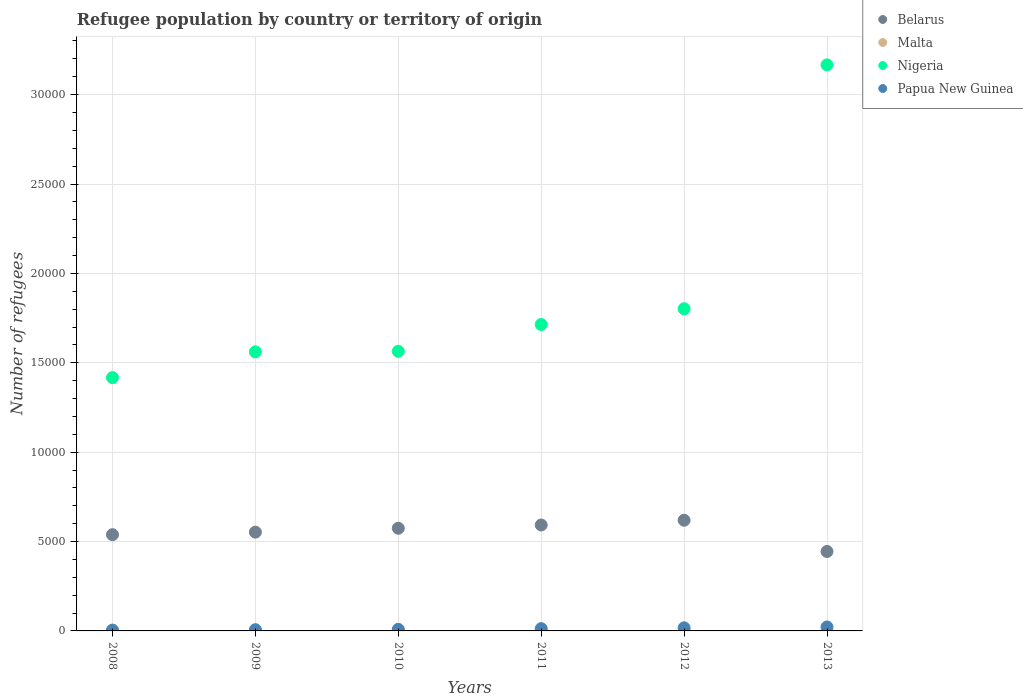Is the number of dotlines equal to the number of legend labels?
Your answer should be compact. Yes. Across all years, what is the minimum number of refugees in Nigeria?
Your answer should be very brief. 1.42e+04. What is the difference between the number of refugees in Nigeria in 2010 and that in 2012?
Your response must be concise. -2379. What is the difference between the number of refugees in Belarus in 2013 and the number of refugees in Nigeria in 2012?
Make the answer very short. -1.36e+04. What is the average number of refugees in Nigeria per year?
Offer a very short reply. 1.87e+04. In the year 2008, what is the difference between the number of refugees in Belarus and number of refugees in Papua New Guinea?
Your answer should be compact. 5338. What is the ratio of the number of refugees in Papua New Guinea in 2010 to that in 2013?
Keep it short and to the point. 0.4. Is the number of refugees in Malta in 2011 less than that in 2013?
Ensure brevity in your answer.  No. Is it the case that in every year, the sum of the number of refugees in Malta and number of refugees in Papua New Guinea  is greater than the sum of number of refugees in Nigeria and number of refugees in Belarus?
Offer a very short reply. No. Does the number of refugees in Nigeria monotonically increase over the years?
Ensure brevity in your answer.  Yes. Is the number of refugees in Belarus strictly greater than the number of refugees in Papua New Guinea over the years?
Your response must be concise. Yes. How many years are there in the graph?
Provide a succinct answer. 6. What is the difference between two consecutive major ticks on the Y-axis?
Your response must be concise. 5000. Does the graph contain grids?
Give a very brief answer. Yes. How are the legend labels stacked?
Give a very brief answer. Vertical. What is the title of the graph?
Keep it short and to the point. Refugee population by country or territory of origin. What is the label or title of the X-axis?
Offer a very short reply. Years. What is the label or title of the Y-axis?
Your answer should be very brief. Number of refugees. What is the Number of refugees in Belarus in 2008?
Your response must be concise. 5384. What is the Number of refugees in Nigeria in 2008?
Your response must be concise. 1.42e+04. What is the Number of refugees of Belarus in 2009?
Offer a terse response. 5525. What is the Number of refugees of Malta in 2009?
Provide a succinct answer. 9. What is the Number of refugees of Nigeria in 2009?
Provide a short and direct response. 1.56e+04. What is the Number of refugees in Papua New Guinea in 2009?
Provide a succinct answer. 70. What is the Number of refugees of Belarus in 2010?
Your response must be concise. 5743. What is the Number of refugees in Nigeria in 2010?
Provide a short and direct response. 1.56e+04. What is the Number of refugees in Papua New Guinea in 2010?
Give a very brief answer. 89. What is the Number of refugees in Belarus in 2011?
Provide a short and direct response. 5925. What is the Number of refugees in Nigeria in 2011?
Make the answer very short. 1.71e+04. What is the Number of refugees of Papua New Guinea in 2011?
Offer a terse response. 128. What is the Number of refugees of Belarus in 2012?
Make the answer very short. 6191. What is the Number of refugees of Malta in 2012?
Ensure brevity in your answer.  6. What is the Number of refugees in Nigeria in 2012?
Keep it short and to the point. 1.80e+04. What is the Number of refugees in Papua New Guinea in 2012?
Make the answer very short. 174. What is the Number of refugees of Belarus in 2013?
Offer a very short reply. 4444. What is the Number of refugees in Malta in 2013?
Provide a short and direct response. 6. What is the Number of refugees in Nigeria in 2013?
Keep it short and to the point. 3.17e+04. What is the Number of refugees in Papua New Guinea in 2013?
Make the answer very short. 221. Across all years, what is the maximum Number of refugees of Belarus?
Provide a succinct answer. 6191. Across all years, what is the maximum Number of refugees in Nigeria?
Give a very brief answer. 3.17e+04. Across all years, what is the maximum Number of refugees in Papua New Guinea?
Offer a terse response. 221. Across all years, what is the minimum Number of refugees of Belarus?
Provide a short and direct response. 4444. Across all years, what is the minimum Number of refugees in Nigeria?
Your answer should be compact. 1.42e+04. Across all years, what is the minimum Number of refugees of Papua New Guinea?
Keep it short and to the point. 46. What is the total Number of refugees of Belarus in the graph?
Make the answer very short. 3.32e+04. What is the total Number of refugees in Malta in the graph?
Your response must be concise. 42. What is the total Number of refugees of Nigeria in the graph?
Offer a very short reply. 1.12e+05. What is the total Number of refugees in Papua New Guinea in the graph?
Offer a terse response. 728. What is the difference between the Number of refugees of Belarus in 2008 and that in 2009?
Keep it short and to the point. -141. What is the difference between the Number of refugees in Malta in 2008 and that in 2009?
Your answer should be very brief. 0. What is the difference between the Number of refugees of Nigeria in 2008 and that in 2009?
Ensure brevity in your answer.  -1440. What is the difference between the Number of refugees of Belarus in 2008 and that in 2010?
Your answer should be compact. -359. What is the difference between the Number of refugees in Nigeria in 2008 and that in 2010?
Your response must be concise. -1473. What is the difference between the Number of refugees in Papua New Guinea in 2008 and that in 2010?
Ensure brevity in your answer.  -43. What is the difference between the Number of refugees in Belarus in 2008 and that in 2011?
Offer a very short reply. -541. What is the difference between the Number of refugees of Malta in 2008 and that in 2011?
Your response must be concise. 3. What is the difference between the Number of refugees in Nigeria in 2008 and that in 2011?
Make the answer very short. -2972. What is the difference between the Number of refugees in Papua New Guinea in 2008 and that in 2011?
Your response must be concise. -82. What is the difference between the Number of refugees of Belarus in 2008 and that in 2012?
Your response must be concise. -807. What is the difference between the Number of refugees of Nigeria in 2008 and that in 2012?
Offer a terse response. -3852. What is the difference between the Number of refugees in Papua New Guinea in 2008 and that in 2012?
Keep it short and to the point. -128. What is the difference between the Number of refugees in Belarus in 2008 and that in 2013?
Your response must be concise. 940. What is the difference between the Number of refugees of Nigeria in 2008 and that in 2013?
Offer a very short reply. -1.75e+04. What is the difference between the Number of refugees in Papua New Guinea in 2008 and that in 2013?
Make the answer very short. -175. What is the difference between the Number of refugees in Belarus in 2009 and that in 2010?
Give a very brief answer. -218. What is the difference between the Number of refugees in Nigeria in 2009 and that in 2010?
Make the answer very short. -33. What is the difference between the Number of refugees of Papua New Guinea in 2009 and that in 2010?
Your answer should be very brief. -19. What is the difference between the Number of refugees in Belarus in 2009 and that in 2011?
Provide a short and direct response. -400. What is the difference between the Number of refugees in Nigeria in 2009 and that in 2011?
Give a very brief answer. -1532. What is the difference between the Number of refugees in Papua New Guinea in 2009 and that in 2011?
Your answer should be compact. -58. What is the difference between the Number of refugees in Belarus in 2009 and that in 2012?
Your response must be concise. -666. What is the difference between the Number of refugees in Nigeria in 2009 and that in 2012?
Provide a short and direct response. -2412. What is the difference between the Number of refugees in Papua New Guinea in 2009 and that in 2012?
Offer a terse response. -104. What is the difference between the Number of refugees in Belarus in 2009 and that in 2013?
Ensure brevity in your answer.  1081. What is the difference between the Number of refugees in Malta in 2009 and that in 2013?
Provide a short and direct response. 3. What is the difference between the Number of refugees in Nigeria in 2009 and that in 2013?
Offer a terse response. -1.61e+04. What is the difference between the Number of refugees of Papua New Guinea in 2009 and that in 2013?
Make the answer very short. -151. What is the difference between the Number of refugees in Belarus in 2010 and that in 2011?
Offer a very short reply. -182. What is the difference between the Number of refugees of Nigeria in 2010 and that in 2011?
Give a very brief answer. -1499. What is the difference between the Number of refugees in Papua New Guinea in 2010 and that in 2011?
Your answer should be compact. -39. What is the difference between the Number of refugees of Belarus in 2010 and that in 2012?
Offer a terse response. -448. What is the difference between the Number of refugees of Nigeria in 2010 and that in 2012?
Your answer should be very brief. -2379. What is the difference between the Number of refugees of Papua New Guinea in 2010 and that in 2012?
Your answer should be compact. -85. What is the difference between the Number of refugees of Belarus in 2010 and that in 2013?
Provide a short and direct response. 1299. What is the difference between the Number of refugees in Nigeria in 2010 and that in 2013?
Provide a short and direct response. -1.60e+04. What is the difference between the Number of refugees in Papua New Guinea in 2010 and that in 2013?
Your answer should be very brief. -132. What is the difference between the Number of refugees in Belarus in 2011 and that in 2012?
Your answer should be very brief. -266. What is the difference between the Number of refugees of Malta in 2011 and that in 2012?
Provide a succinct answer. 0. What is the difference between the Number of refugees in Nigeria in 2011 and that in 2012?
Your answer should be very brief. -880. What is the difference between the Number of refugees in Papua New Guinea in 2011 and that in 2012?
Provide a short and direct response. -46. What is the difference between the Number of refugees in Belarus in 2011 and that in 2013?
Offer a terse response. 1481. What is the difference between the Number of refugees in Malta in 2011 and that in 2013?
Offer a terse response. 0. What is the difference between the Number of refugees in Nigeria in 2011 and that in 2013?
Make the answer very short. -1.45e+04. What is the difference between the Number of refugees in Papua New Guinea in 2011 and that in 2013?
Your response must be concise. -93. What is the difference between the Number of refugees in Belarus in 2012 and that in 2013?
Your answer should be very brief. 1747. What is the difference between the Number of refugees in Malta in 2012 and that in 2013?
Provide a succinct answer. 0. What is the difference between the Number of refugees of Nigeria in 2012 and that in 2013?
Your response must be concise. -1.36e+04. What is the difference between the Number of refugees of Papua New Guinea in 2012 and that in 2013?
Your answer should be compact. -47. What is the difference between the Number of refugees in Belarus in 2008 and the Number of refugees in Malta in 2009?
Keep it short and to the point. 5375. What is the difference between the Number of refugees in Belarus in 2008 and the Number of refugees in Nigeria in 2009?
Keep it short and to the point. -1.02e+04. What is the difference between the Number of refugees of Belarus in 2008 and the Number of refugees of Papua New Guinea in 2009?
Offer a terse response. 5314. What is the difference between the Number of refugees in Malta in 2008 and the Number of refugees in Nigeria in 2009?
Keep it short and to the point. -1.56e+04. What is the difference between the Number of refugees in Malta in 2008 and the Number of refugees in Papua New Guinea in 2009?
Make the answer very short. -61. What is the difference between the Number of refugees in Nigeria in 2008 and the Number of refugees in Papua New Guinea in 2009?
Offer a terse response. 1.41e+04. What is the difference between the Number of refugees of Belarus in 2008 and the Number of refugees of Malta in 2010?
Provide a succinct answer. 5378. What is the difference between the Number of refugees in Belarus in 2008 and the Number of refugees in Nigeria in 2010?
Offer a very short reply. -1.03e+04. What is the difference between the Number of refugees of Belarus in 2008 and the Number of refugees of Papua New Guinea in 2010?
Give a very brief answer. 5295. What is the difference between the Number of refugees of Malta in 2008 and the Number of refugees of Nigeria in 2010?
Your response must be concise. -1.56e+04. What is the difference between the Number of refugees in Malta in 2008 and the Number of refugees in Papua New Guinea in 2010?
Your answer should be very brief. -80. What is the difference between the Number of refugees in Nigeria in 2008 and the Number of refugees in Papua New Guinea in 2010?
Give a very brief answer. 1.41e+04. What is the difference between the Number of refugees in Belarus in 2008 and the Number of refugees in Malta in 2011?
Provide a succinct answer. 5378. What is the difference between the Number of refugees in Belarus in 2008 and the Number of refugees in Nigeria in 2011?
Make the answer very short. -1.18e+04. What is the difference between the Number of refugees of Belarus in 2008 and the Number of refugees of Papua New Guinea in 2011?
Provide a short and direct response. 5256. What is the difference between the Number of refugees in Malta in 2008 and the Number of refugees in Nigeria in 2011?
Ensure brevity in your answer.  -1.71e+04. What is the difference between the Number of refugees in Malta in 2008 and the Number of refugees in Papua New Guinea in 2011?
Provide a short and direct response. -119. What is the difference between the Number of refugees of Nigeria in 2008 and the Number of refugees of Papua New Guinea in 2011?
Your answer should be very brief. 1.40e+04. What is the difference between the Number of refugees of Belarus in 2008 and the Number of refugees of Malta in 2012?
Provide a succinct answer. 5378. What is the difference between the Number of refugees of Belarus in 2008 and the Number of refugees of Nigeria in 2012?
Provide a succinct answer. -1.26e+04. What is the difference between the Number of refugees of Belarus in 2008 and the Number of refugees of Papua New Guinea in 2012?
Provide a short and direct response. 5210. What is the difference between the Number of refugees of Malta in 2008 and the Number of refugees of Nigeria in 2012?
Ensure brevity in your answer.  -1.80e+04. What is the difference between the Number of refugees in Malta in 2008 and the Number of refugees in Papua New Guinea in 2012?
Make the answer very short. -165. What is the difference between the Number of refugees of Nigeria in 2008 and the Number of refugees of Papua New Guinea in 2012?
Your answer should be very brief. 1.40e+04. What is the difference between the Number of refugees in Belarus in 2008 and the Number of refugees in Malta in 2013?
Provide a short and direct response. 5378. What is the difference between the Number of refugees in Belarus in 2008 and the Number of refugees in Nigeria in 2013?
Ensure brevity in your answer.  -2.63e+04. What is the difference between the Number of refugees of Belarus in 2008 and the Number of refugees of Papua New Guinea in 2013?
Provide a short and direct response. 5163. What is the difference between the Number of refugees in Malta in 2008 and the Number of refugees in Nigeria in 2013?
Offer a very short reply. -3.17e+04. What is the difference between the Number of refugees of Malta in 2008 and the Number of refugees of Papua New Guinea in 2013?
Provide a succinct answer. -212. What is the difference between the Number of refugees of Nigeria in 2008 and the Number of refugees of Papua New Guinea in 2013?
Keep it short and to the point. 1.39e+04. What is the difference between the Number of refugees in Belarus in 2009 and the Number of refugees in Malta in 2010?
Provide a short and direct response. 5519. What is the difference between the Number of refugees in Belarus in 2009 and the Number of refugees in Nigeria in 2010?
Ensure brevity in your answer.  -1.01e+04. What is the difference between the Number of refugees in Belarus in 2009 and the Number of refugees in Papua New Guinea in 2010?
Ensure brevity in your answer.  5436. What is the difference between the Number of refugees in Malta in 2009 and the Number of refugees in Nigeria in 2010?
Provide a succinct answer. -1.56e+04. What is the difference between the Number of refugees of Malta in 2009 and the Number of refugees of Papua New Guinea in 2010?
Offer a terse response. -80. What is the difference between the Number of refugees in Nigeria in 2009 and the Number of refugees in Papua New Guinea in 2010?
Offer a very short reply. 1.55e+04. What is the difference between the Number of refugees in Belarus in 2009 and the Number of refugees in Malta in 2011?
Provide a succinct answer. 5519. What is the difference between the Number of refugees in Belarus in 2009 and the Number of refugees in Nigeria in 2011?
Provide a short and direct response. -1.16e+04. What is the difference between the Number of refugees in Belarus in 2009 and the Number of refugees in Papua New Guinea in 2011?
Make the answer very short. 5397. What is the difference between the Number of refugees of Malta in 2009 and the Number of refugees of Nigeria in 2011?
Your response must be concise. -1.71e+04. What is the difference between the Number of refugees in Malta in 2009 and the Number of refugees in Papua New Guinea in 2011?
Your answer should be compact. -119. What is the difference between the Number of refugees in Nigeria in 2009 and the Number of refugees in Papua New Guinea in 2011?
Your answer should be very brief. 1.55e+04. What is the difference between the Number of refugees in Belarus in 2009 and the Number of refugees in Malta in 2012?
Give a very brief answer. 5519. What is the difference between the Number of refugees of Belarus in 2009 and the Number of refugees of Nigeria in 2012?
Make the answer very short. -1.25e+04. What is the difference between the Number of refugees in Belarus in 2009 and the Number of refugees in Papua New Guinea in 2012?
Your answer should be very brief. 5351. What is the difference between the Number of refugees in Malta in 2009 and the Number of refugees in Nigeria in 2012?
Keep it short and to the point. -1.80e+04. What is the difference between the Number of refugees of Malta in 2009 and the Number of refugees of Papua New Guinea in 2012?
Keep it short and to the point. -165. What is the difference between the Number of refugees of Nigeria in 2009 and the Number of refugees of Papua New Guinea in 2012?
Ensure brevity in your answer.  1.54e+04. What is the difference between the Number of refugees in Belarus in 2009 and the Number of refugees in Malta in 2013?
Make the answer very short. 5519. What is the difference between the Number of refugees of Belarus in 2009 and the Number of refugees of Nigeria in 2013?
Keep it short and to the point. -2.61e+04. What is the difference between the Number of refugees in Belarus in 2009 and the Number of refugees in Papua New Guinea in 2013?
Ensure brevity in your answer.  5304. What is the difference between the Number of refugees in Malta in 2009 and the Number of refugees in Nigeria in 2013?
Give a very brief answer. -3.17e+04. What is the difference between the Number of refugees of Malta in 2009 and the Number of refugees of Papua New Guinea in 2013?
Your answer should be compact. -212. What is the difference between the Number of refugees of Nigeria in 2009 and the Number of refugees of Papua New Guinea in 2013?
Offer a very short reply. 1.54e+04. What is the difference between the Number of refugees of Belarus in 2010 and the Number of refugees of Malta in 2011?
Make the answer very short. 5737. What is the difference between the Number of refugees in Belarus in 2010 and the Number of refugees in Nigeria in 2011?
Give a very brief answer. -1.14e+04. What is the difference between the Number of refugees of Belarus in 2010 and the Number of refugees of Papua New Guinea in 2011?
Ensure brevity in your answer.  5615. What is the difference between the Number of refugees in Malta in 2010 and the Number of refugees in Nigeria in 2011?
Provide a succinct answer. -1.71e+04. What is the difference between the Number of refugees in Malta in 2010 and the Number of refugees in Papua New Guinea in 2011?
Provide a short and direct response. -122. What is the difference between the Number of refugees in Nigeria in 2010 and the Number of refugees in Papua New Guinea in 2011?
Offer a terse response. 1.55e+04. What is the difference between the Number of refugees of Belarus in 2010 and the Number of refugees of Malta in 2012?
Make the answer very short. 5737. What is the difference between the Number of refugees in Belarus in 2010 and the Number of refugees in Nigeria in 2012?
Keep it short and to the point. -1.23e+04. What is the difference between the Number of refugees of Belarus in 2010 and the Number of refugees of Papua New Guinea in 2012?
Your response must be concise. 5569. What is the difference between the Number of refugees of Malta in 2010 and the Number of refugees of Nigeria in 2012?
Ensure brevity in your answer.  -1.80e+04. What is the difference between the Number of refugees in Malta in 2010 and the Number of refugees in Papua New Guinea in 2012?
Provide a succinct answer. -168. What is the difference between the Number of refugees in Nigeria in 2010 and the Number of refugees in Papua New Guinea in 2012?
Ensure brevity in your answer.  1.55e+04. What is the difference between the Number of refugees of Belarus in 2010 and the Number of refugees of Malta in 2013?
Make the answer very short. 5737. What is the difference between the Number of refugees in Belarus in 2010 and the Number of refugees in Nigeria in 2013?
Offer a terse response. -2.59e+04. What is the difference between the Number of refugees of Belarus in 2010 and the Number of refugees of Papua New Guinea in 2013?
Keep it short and to the point. 5522. What is the difference between the Number of refugees of Malta in 2010 and the Number of refugees of Nigeria in 2013?
Make the answer very short. -3.17e+04. What is the difference between the Number of refugees in Malta in 2010 and the Number of refugees in Papua New Guinea in 2013?
Offer a very short reply. -215. What is the difference between the Number of refugees in Nigeria in 2010 and the Number of refugees in Papua New Guinea in 2013?
Provide a short and direct response. 1.54e+04. What is the difference between the Number of refugees in Belarus in 2011 and the Number of refugees in Malta in 2012?
Give a very brief answer. 5919. What is the difference between the Number of refugees in Belarus in 2011 and the Number of refugees in Nigeria in 2012?
Make the answer very short. -1.21e+04. What is the difference between the Number of refugees of Belarus in 2011 and the Number of refugees of Papua New Guinea in 2012?
Provide a short and direct response. 5751. What is the difference between the Number of refugees in Malta in 2011 and the Number of refugees in Nigeria in 2012?
Provide a short and direct response. -1.80e+04. What is the difference between the Number of refugees of Malta in 2011 and the Number of refugees of Papua New Guinea in 2012?
Give a very brief answer. -168. What is the difference between the Number of refugees in Nigeria in 2011 and the Number of refugees in Papua New Guinea in 2012?
Give a very brief answer. 1.70e+04. What is the difference between the Number of refugees in Belarus in 2011 and the Number of refugees in Malta in 2013?
Offer a terse response. 5919. What is the difference between the Number of refugees in Belarus in 2011 and the Number of refugees in Nigeria in 2013?
Offer a very short reply. -2.57e+04. What is the difference between the Number of refugees in Belarus in 2011 and the Number of refugees in Papua New Guinea in 2013?
Your answer should be compact. 5704. What is the difference between the Number of refugees of Malta in 2011 and the Number of refugees of Nigeria in 2013?
Make the answer very short. -3.17e+04. What is the difference between the Number of refugees in Malta in 2011 and the Number of refugees in Papua New Guinea in 2013?
Your answer should be very brief. -215. What is the difference between the Number of refugees of Nigeria in 2011 and the Number of refugees of Papua New Guinea in 2013?
Keep it short and to the point. 1.69e+04. What is the difference between the Number of refugees in Belarus in 2012 and the Number of refugees in Malta in 2013?
Your answer should be compact. 6185. What is the difference between the Number of refugees in Belarus in 2012 and the Number of refugees in Nigeria in 2013?
Make the answer very short. -2.55e+04. What is the difference between the Number of refugees in Belarus in 2012 and the Number of refugees in Papua New Guinea in 2013?
Offer a very short reply. 5970. What is the difference between the Number of refugees of Malta in 2012 and the Number of refugees of Nigeria in 2013?
Your answer should be compact. -3.17e+04. What is the difference between the Number of refugees in Malta in 2012 and the Number of refugees in Papua New Guinea in 2013?
Your answer should be compact. -215. What is the difference between the Number of refugees of Nigeria in 2012 and the Number of refugees of Papua New Guinea in 2013?
Give a very brief answer. 1.78e+04. What is the average Number of refugees in Belarus per year?
Provide a succinct answer. 5535.33. What is the average Number of refugees in Nigeria per year?
Provide a short and direct response. 1.87e+04. What is the average Number of refugees in Papua New Guinea per year?
Provide a succinct answer. 121.33. In the year 2008, what is the difference between the Number of refugees of Belarus and Number of refugees of Malta?
Keep it short and to the point. 5375. In the year 2008, what is the difference between the Number of refugees in Belarus and Number of refugees in Nigeria?
Your answer should be very brief. -8785. In the year 2008, what is the difference between the Number of refugees of Belarus and Number of refugees of Papua New Guinea?
Give a very brief answer. 5338. In the year 2008, what is the difference between the Number of refugees of Malta and Number of refugees of Nigeria?
Your answer should be compact. -1.42e+04. In the year 2008, what is the difference between the Number of refugees in Malta and Number of refugees in Papua New Guinea?
Keep it short and to the point. -37. In the year 2008, what is the difference between the Number of refugees of Nigeria and Number of refugees of Papua New Guinea?
Provide a succinct answer. 1.41e+04. In the year 2009, what is the difference between the Number of refugees of Belarus and Number of refugees of Malta?
Provide a short and direct response. 5516. In the year 2009, what is the difference between the Number of refugees of Belarus and Number of refugees of Nigeria?
Your answer should be compact. -1.01e+04. In the year 2009, what is the difference between the Number of refugees in Belarus and Number of refugees in Papua New Guinea?
Your answer should be very brief. 5455. In the year 2009, what is the difference between the Number of refugees of Malta and Number of refugees of Nigeria?
Provide a succinct answer. -1.56e+04. In the year 2009, what is the difference between the Number of refugees in Malta and Number of refugees in Papua New Guinea?
Offer a very short reply. -61. In the year 2009, what is the difference between the Number of refugees in Nigeria and Number of refugees in Papua New Guinea?
Make the answer very short. 1.55e+04. In the year 2010, what is the difference between the Number of refugees in Belarus and Number of refugees in Malta?
Provide a short and direct response. 5737. In the year 2010, what is the difference between the Number of refugees in Belarus and Number of refugees in Nigeria?
Your answer should be very brief. -9899. In the year 2010, what is the difference between the Number of refugees of Belarus and Number of refugees of Papua New Guinea?
Provide a short and direct response. 5654. In the year 2010, what is the difference between the Number of refugees of Malta and Number of refugees of Nigeria?
Offer a terse response. -1.56e+04. In the year 2010, what is the difference between the Number of refugees of Malta and Number of refugees of Papua New Guinea?
Your answer should be compact. -83. In the year 2010, what is the difference between the Number of refugees of Nigeria and Number of refugees of Papua New Guinea?
Provide a succinct answer. 1.56e+04. In the year 2011, what is the difference between the Number of refugees in Belarus and Number of refugees in Malta?
Your response must be concise. 5919. In the year 2011, what is the difference between the Number of refugees in Belarus and Number of refugees in Nigeria?
Ensure brevity in your answer.  -1.12e+04. In the year 2011, what is the difference between the Number of refugees in Belarus and Number of refugees in Papua New Guinea?
Your answer should be compact. 5797. In the year 2011, what is the difference between the Number of refugees of Malta and Number of refugees of Nigeria?
Provide a succinct answer. -1.71e+04. In the year 2011, what is the difference between the Number of refugees of Malta and Number of refugees of Papua New Guinea?
Keep it short and to the point. -122. In the year 2011, what is the difference between the Number of refugees of Nigeria and Number of refugees of Papua New Guinea?
Your response must be concise. 1.70e+04. In the year 2012, what is the difference between the Number of refugees of Belarus and Number of refugees of Malta?
Provide a succinct answer. 6185. In the year 2012, what is the difference between the Number of refugees of Belarus and Number of refugees of Nigeria?
Give a very brief answer. -1.18e+04. In the year 2012, what is the difference between the Number of refugees of Belarus and Number of refugees of Papua New Guinea?
Your answer should be compact. 6017. In the year 2012, what is the difference between the Number of refugees of Malta and Number of refugees of Nigeria?
Ensure brevity in your answer.  -1.80e+04. In the year 2012, what is the difference between the Number of refugees in Malta and Number of refugees in Papua New Guinea?
Offer a very short reply. -168. In the year 2012, what is the difference between the Number of refugees in Nigeria and Number of refugees in Papua New Guinea?
Your answer should be compact. 1.78e+04. In the year 2013, what is the difference between the Number of refugees in Belarus and Number of refugees in Malta?
Make the answer very short. 4438. In the year 2013, what is the difference between the Number of refugees of Belarus and Number of refugees of Nigeria?
Your answer should be compact. -2.72e+04. In the year 2013, what is the difference between the Number of refugees in Belarus and Number of refugees in Papua New Guinea?
Ensure brevity in your answer.  4223. In the year 2013, what is the difference between the Number of refugees in Malta and Number of refugees in Nigeria?
Provide a short and direct response. -3.17e+04. In the year 2013, what is the difference between the Number of refugees of Malta and Number of refugees of Papua New Guinea?
Make the answer very short. -215. In the year 2013, what is the difference between the Number of refugees of Nigeria and Number of refugees of Papua New Guinea?
Keep it short and to the point. 3.14e+04. What is the ratio of the Number of refugees in Belarus in 2008 to that in 2009?
Make the answer very short. 0.97. What is the ratio of the Number of refugees in Malta in 2008 to that in 2009?
Keep it short and to the point. 1. What is the ratio of the Number of refugees in Nigeria in 2008 to that in 2009?
Ensure brevity in your answer.  0.91. What is the ratio of the Number of refugees in Papua New Guinea in 2008 to that in 2009?
Keep it short and to the point. 0.66. What is the ratio of the Number of refugees in Belarus in 2008 to that in 2010?
Your answer should be compact. 0.94. What is the ratio of the Number of refugees in Malta in 2008 to that in 2010?
Provide a succinct answer. 1.5. What is the ratio of the Number of refugees in Nigeria in 2008 to that in 2010?
Provide a short and direct response. 0.91. What is the ratio of the Number of refugees in Papua New Guinea in 2008 to that in 2010?
Give a very brief answer. 0.52. What is the ratio of the Number of refugees of Belarus in 2008 to that in 2011?
Offer a very short reply. 0.91. What is the ratio of the Number of refugees in Nigeria in 2008 to that in 2011?
Your answer should be compact. 0.83. What is the ratio of the Number of refugees in Papua New Guinea in 2008 to that in 2011?
Your response must be concise. 0.36. What is the ratio of the Number of refugees in Belarus in 2008 to that in 2012?
Make the answer very short. 0.87. What is the ratio of the Number of refugees in Malta in 2008 to that in 2012?
Provide a succinct answer. 1.5. What is the ratio of the Number of refugees in Nigeria in 2008 to that in 2012?
Offer a very short reply. 0.79. What is the ratio of the Number of refugees of Papua New Guinea in 2008 to that in 2012?
Offer a terse response. 0.26. What is the ratio of the Number of refugees in Belarus in 2008 to that in 2013?
Provide a short and direct response. 1.21. What is the ratio of the Number of refugees in Nigeria in 2008 to that in 2013?
Offer a terse response. 0.45. What is the ratio of the Number of refugees in Papua New Guinea in 2008 to that in 2013?
Your answer should be very brief. 0.21. What is the ratio of the Number of refugees of Papua New Guinea in 2009 to that in 2010?
Make the answer very short. 0.79. What is the ratio of the Number of refugees of Belarus in 2009 to that in 2011?
Provide a short and direct response. 0.93. What is the ratio of the Number of refugees in Nigeria in 2009 to that in 2011?
Ensure brevity in your answer.  0.91. What is the ratio of the Number of refugees in Papua New Guinea in 2009 to that in 2011?
Keep it short and to the point. 0.55. What is the ratio of the Number of refugees in Belarus in 2009 to that in 2012?
Keep it short and to the point. 0.89. What is the ratio of the Number of refugees in Nigeria in 2009 to that in 2012?
Provide a short and direct response. 0.87. What is the ratio of the Number of refugees in Papua New Guinea in 2009 to that in 2012?
Your answer should be compact. 0.4. What is the ratio of the Number of refugees in Belarus in 2009 to that in 2013?
Give a very brief answer. 1.24. What is the ratio of the Number of refugees of Nigeria in 2009 to that in 2013?
Provide a short and direct response. 0.49. What is the ratio of the Number of refugees of Papua New Guinea in 2009 to that in 2013?
Ensure brevity in your answer.  0.32. What is the ratio of the Number of refugees in Belarus in 2010 to that in 2011?
Provide a succinct answer. 0.97. What is the ratio of the Number of refugees of Nigeria in 2010 to that in 2011?
Provide a succinct answer. 0.91. What is the ratio of the Number of refugees in Papua New Guinea in 2010 to that in 2011?
Give a very brief answer. 0.7. What is the ratio of the Number of refugees in Belarus in 2010 to that in 2012?
Provide a succinct answer. 0.93. What is the ratio of the Number of refugees of Malta in 2010 to that in 2012?
Your response must be concise. 1. What is the ratio of the Number of refugees of Nigeria in 2010 to that in 2012?
Your answer should be very brief. 0.87. What is the ratio of the Number of refugees in Papua New Guinea in 2010 to that in 2012?
Make the answer very short. 0.51. What is the ratio of the Number of refugees of Belarus in 2010 to that in 2013?
Ensure brevity in your answer.  1.29. What is the ratio of the Number of refugees of Nigeria in 2010 to that in 2013?
Ensure brevity in your answer.  0.49. What is the ratio of the Number of refugees of Papua New Guinea in 2010 to that in 2013?
Make the answer very short. 0.4. What is the ratio of the Number of refugees in Belarus in 2011 to that in 2012?
Your answer should be compact. 0.96. What is the ratio of the Number of refugees in Malta in 2011 to that in 2012?
Offer a terse response. 1. What is the ratio of the Number of refugees in Nigeria in 2011 to that in 2012?
Offer a very short reply. 0.95. What is the ratio of the Number of refugees of Papua New Guinea in 2011 to that in 2012?
Ensure brevity in your answer.  0.74. What is the ratio of the Number of refugees in Belarus in 2011 to that in 2013?
Provide a succinct answer. 1.33. What is the ratio of the Number of refugees of Nigeria in 2011 to that in 2013?
Your answer should be very brief. 0.54. What is the ratio of the Number of refugees in Papua New Guinea in 2011 to that in 2013?
Your answer should be compact. 0.58. What is the ratio of the Number of refugees in Belarus in 2012 to that in 2013?
Provide a short and direct response. 1.39. What is the ratio of the Number of refugees of Malta in 2012 to that in 2013?
Make the answer very short. 1. What is the ratio of the Number of refugees of Nigeria in 2012 to that in 2013?
Ensure brevity in your answer.  0.57. What is the ratio of the Number of refugees in Papua New Guinea in 2012 to that in 2013?
Keep it short and to the point. 0.79. What is the difference between the highest and the second highest Number of refugees in Belarus?
Provide a short and direct response. 266. What is the difference between the highest and the second highest Number of refugees of Nigeria?
Ensure brevity in your answer.  1.36e+04. What is the difference between the highest and the second highest Number of refugees in Papua New Guinea?
Offer a very short reply. 47. What is the difference between the highest and the lowest Number of refugees of Belarus?
Offer a very short reply. 1747. What is the difference between the highest and the lowest Number of refugees in Nigeria?
Give a very brief answer. 1.75e+04. What is the difference between the highest and the lowest Number of refugees in Papua New Guinea?
Provide a succinct answer. 175. 